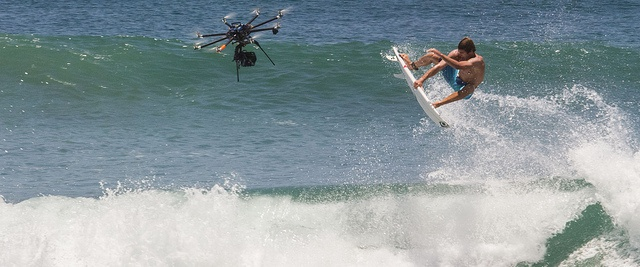Describe the objects in this image and their specific colors. I can see people in gray, maroon, and brown tones and surfboard in gray, darkgray, and lightgray tones in this image. 